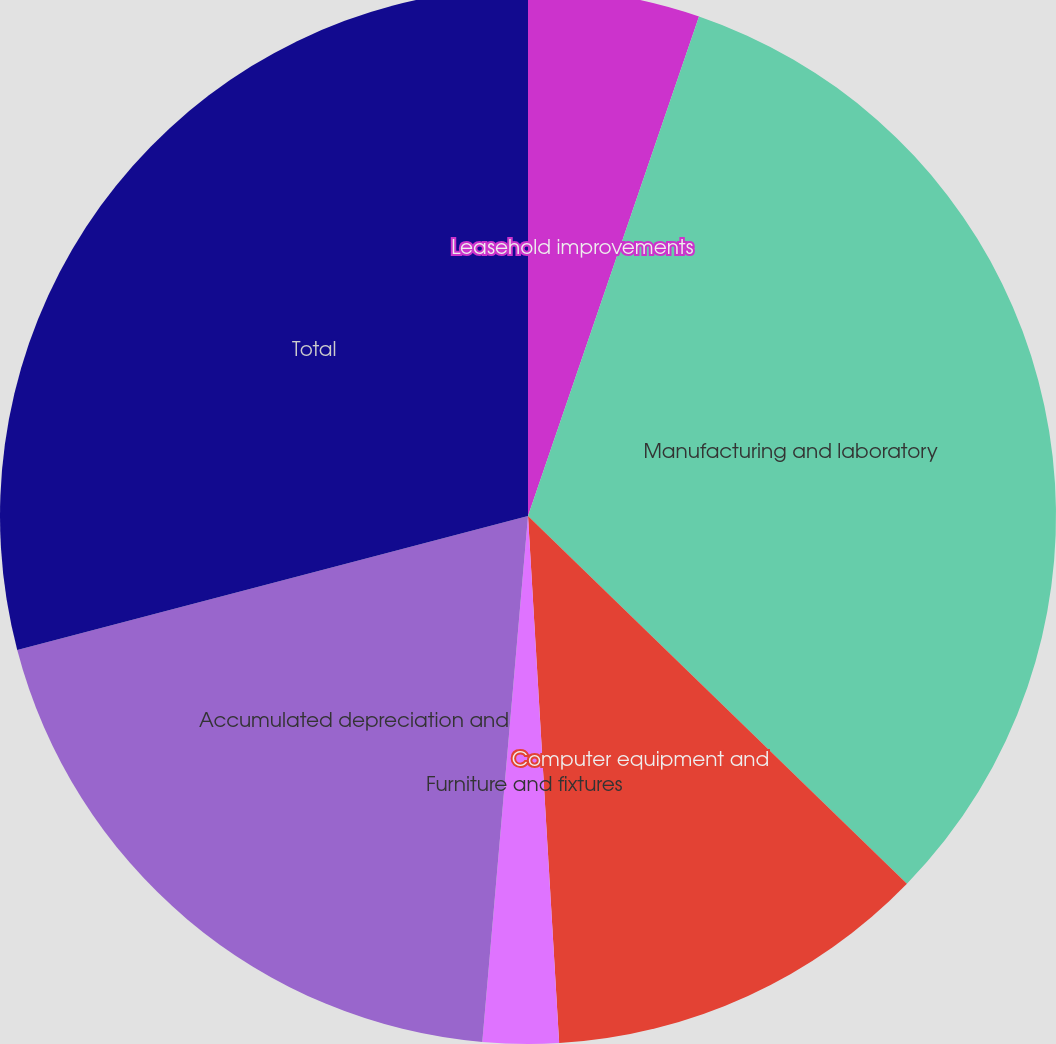<chart> <loc_0><loc_0><loc_500><loc_500><pie_chart><fcel>Leasehold improvements<fcel>Manufacturing and laboratory<fcel>Computer equipment and<fcel>Furniture and fixtures<fcel>Accumulated depreciation and<fcel>Total<nl><fcel>5.25%<fcel>32.01%<fcel>11.8%<fcel>2.32%<fcel>19.54%<fcel>29.08%<nl></chart> 